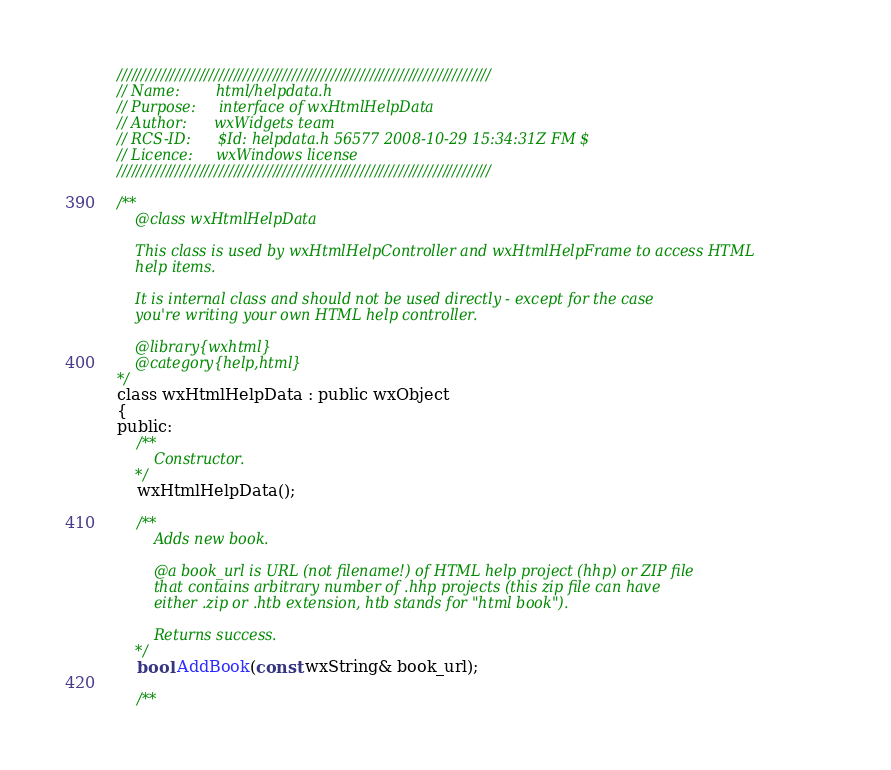<code> <loc_0><loc_0><loc_500><loc_500><_C_>/////////////////////////////////////////////////////////////////////////////
// Name:        html/helpdata.h
// Purpose:     interface of wxHtmlHelpData
// Author:      wxWidgets team
// RCS-ID:      $Id: helpdata.h 56577 2008-10-29 15:34:31Z FM $
// Licence:     wxWindows license
/////////////////////////////////////////////////////////////////////////////

/**
    @class wxHtmlHelpData

    This class is used by wxHtmlHelpController and wxHtmlHelpFrame to access HTML
    help items.

    It is internal class and should not be used directly - except for the case
    you're writing your own HTML help controller.

    @library{wxhtml}
    @category{help,html}
*/
class wxHtmlHelpData : public wxObject
{
public:
    /**
        Constructor.
    */
    wxHtmlHelpData();

    /**
        Adds new book.

        @a book_url is URL (not filename!) of HTML help project (hhp) or ZIP file
        that contains arbitrary number of .hhp projects (this zip file can have
        either .zip or .htb extension, htb stands for "html book").

        Returns success.
    */
    bool AddBook(const wxString& book_url);

    /**</code> 